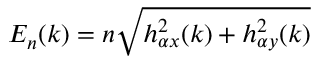<formula> <loc_0><loc_0><loc_500><loc_500>E _ { n } ( k ) = n \sqrt { h _ { \alpha x } ^ { 2 } ( k ) + h _ { \alpha y } ^ { 2 } ( k ) }</formula> 